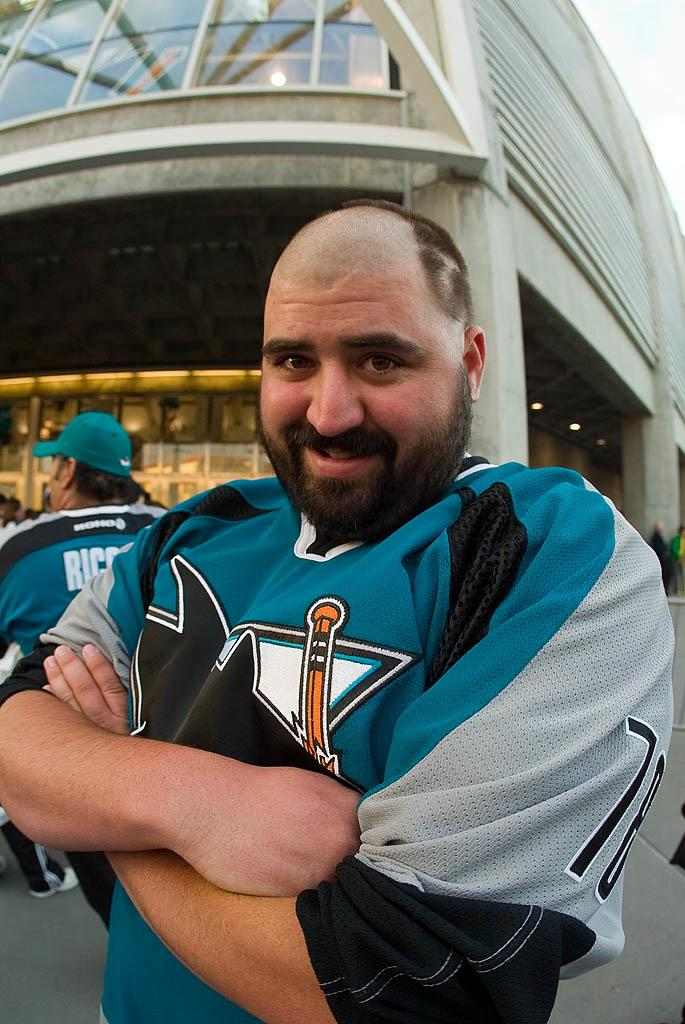How many people are present in the image? There are two persons in the image. Can you describe the background of the image? There is a building in the background of the image. What type of chalk is being used by the rabbits in the image? There are no rabbits present in the image, and therefore no chalk can be observed. 